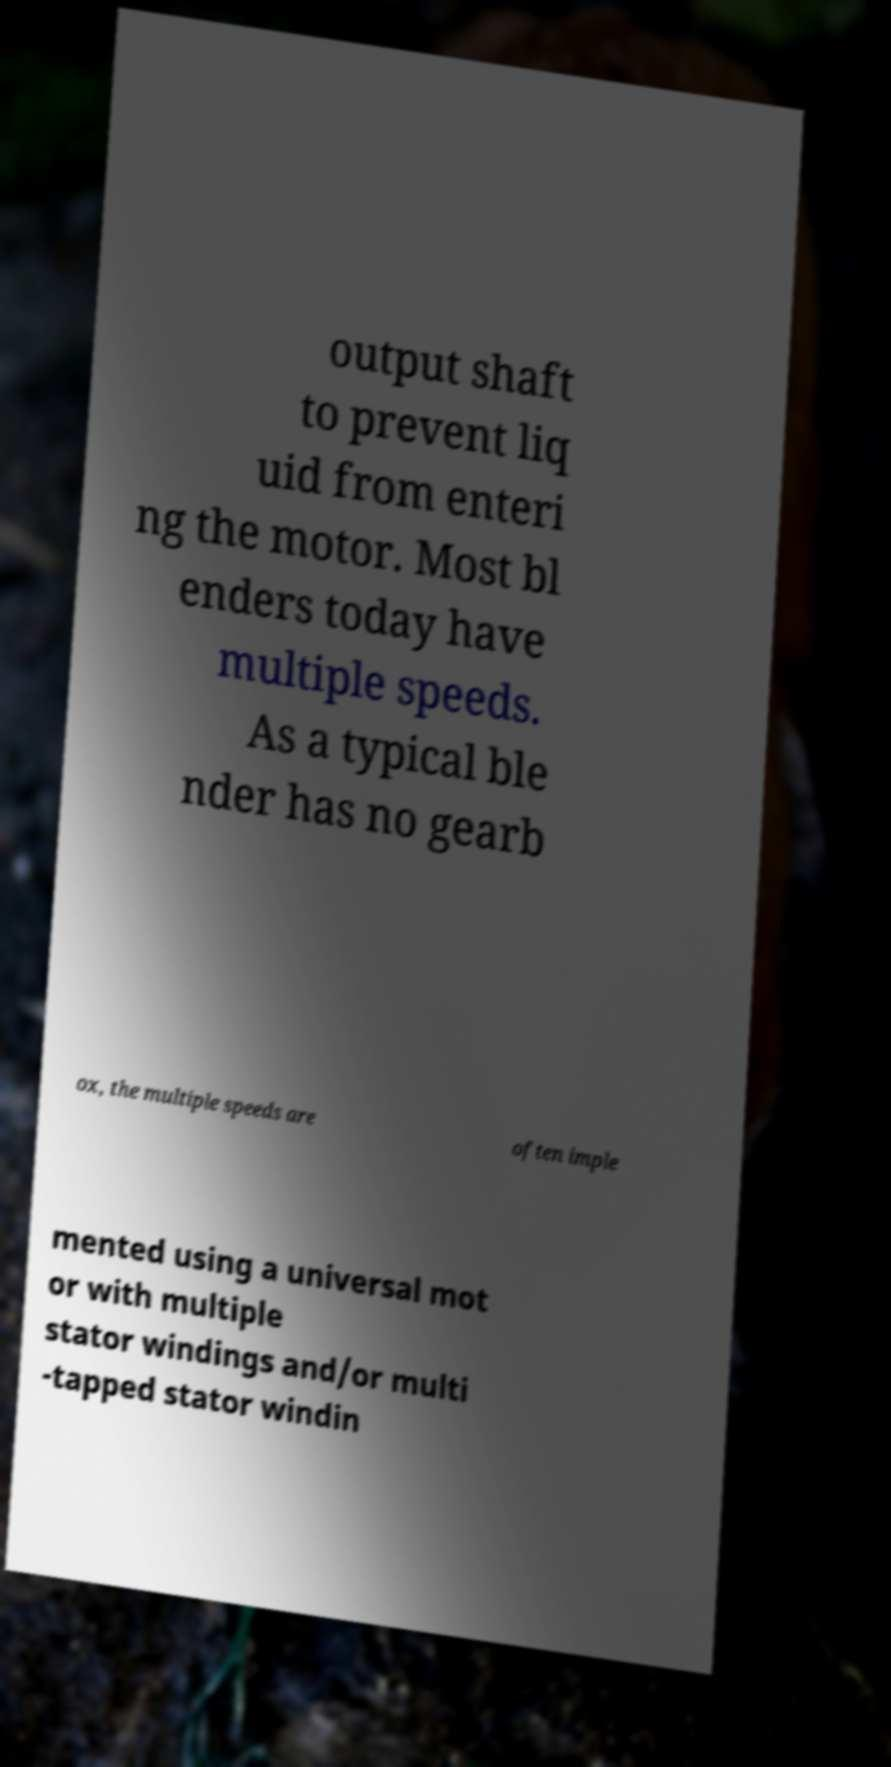For documentation purposes, I need the text within this image transcribed. Could you provide that? output shaft to prevent liq uid from enteri ng the motor. Most bl enders today have multiple speeds. As a typical ble nder has no gearb ox, the multiple speeds are often imple mented using a universal mot or with multiple stator windings and/or multi -tapped stator windin 